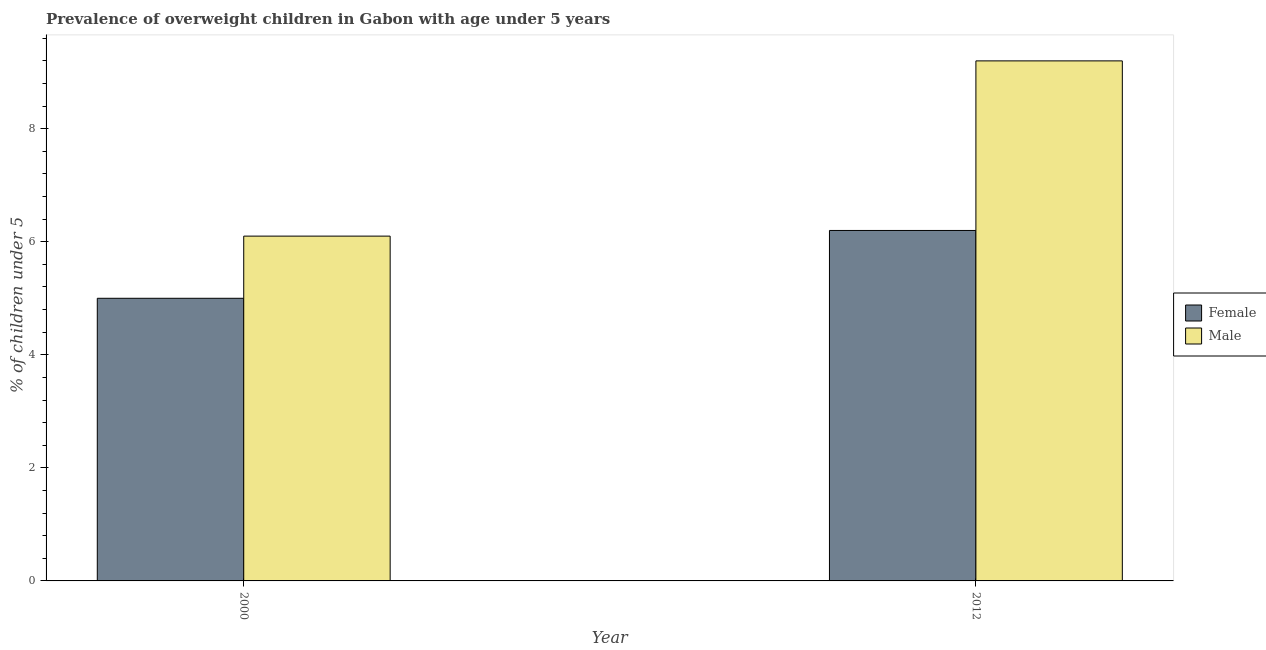Are the number of bars on each tick of the X-axis equal?
Provide a succinct answer. Yes. How many bars are there on the 1st tick from the left?
Your answer should be compact. 2. In how many cases, is the number of bars for a given year not equal to the number of legend labels?
Offer a terse response. 0. What is the percentage of obese male children in 2000?
Make the answer very short. 6.1. Across all years, what is the maximum percentage of obese male children?
Offer a very short reply. 9.2. Across all years, what is the minimum percentage of obese female children?
Your answer should be very brief. 5. In which year was the percentage of obese male children maximum?
Give a very brief answer. 2012. What is the total percentage of obese male children in the graph?
Give a very brief answer. 15.3. What is the difference between the percentage of obese male children in 2000 and that in 2012?
Provide a succinct answer. -3.1. What is the difference between the percentage of obese male children in 2012 and the percentage of obese female children in 2000?
Your answer should be compact. 3.1. What is the average percentage of obese male children per year?
Offer a terse response. 7.65. In the year 2012, what is the difference between the percentage of obese male children and percentage of obese female children?
Your response must be concise. 0. In how many years, is the percentage of obese female children greater than 2 %?
Your answer should be very brief. 2. What is the ratio of the percentage of obese male children in 2000 to that in 2012?
Offer a very short reply. 0.66. In how many years, is the percentage of obese male children greater than the average percentage of obese male children taken over all years?
Ensure brevity in your answer.  1. What does the 1st bar from the left in 2012 represents?
Keep it short and to the point. Female. What does the 1st bar from the right in 2000 represents?
Give a very brief answer. Male. How many bars are there?
Offer a terse response. 4. Are the values on the major ticks of Y-axis written in scientific E-notation?
Provide a short and direct response. No. Does the graph contain grids?
Offer a very short reply. No. How many legend labels are there?
Offer a terse response. 2. What is the title of the graph?
Your answer should be very brief. Prevalence of overweight children in Gabon with age under 5 years. Does "Official creditors" appear as one of the legend labels in the graph?
Provide a short and direct response. No. What is the label or title of the Y-axis?
Offer a very short reply.  % of children under 5. What is the  % of children under 5 in Male in 2000?
Offer a terse response. 6.1. What is the  % of children under 5 of Female in 2012?
Give a very brief answer. 6.2. What is the  % of children under 5 in Male in 2012?
Your answer should be very brief. 9.2. Across all years, what is the maximum  % of children under 5 in Female?
Make the answer very short. 6.2. Across all years, what is the maximum  % of children under 5 of Male?
Provide a short and direct response. 9.2. Across all years, what is the minimum  % of children under 5 of Female?
Offer a very short reply. 5. Across all years, what is the minimum  % of children under 5 of Male?
Provide a succinct answer. 6.1. What is the total  % of children under 5 in Female in the graph?
Ensure brevity in your answer.  11.2. What is the difference between the  % of children under 5 of Male in 2000 and that in 2012?
Provide a short and direct response. -3.1. What is the difference between the  % of children under 5 in Female in 2000 and the  % of children under 5 in Male in 2012?
Your answer should be compact. -4.2. What is the average  % of children under 5 of Male per year?
Provide a succinct answer. 7.65. In the year 2000, what is the difference between the  % of children under 5 in Female and  % of children under 5 in Male?
Your response must be concise. -1.1. What is the ratio of the  % of children under 5 in Female in 2000 to that in 2012?
Your answer should be compact. 0.81. What is the ratio of the  % of children under 5 of Male in 2000 to that in 2012?
Your answer should be compact. 0.66. What is the difference between the highest and the second highest  % of children under 5 in Female?
Give a very brief answer. 1.2. What is the difference between the highest and the lowest  % of children under 5 of Male?
Your response must be concise. 3.1. 